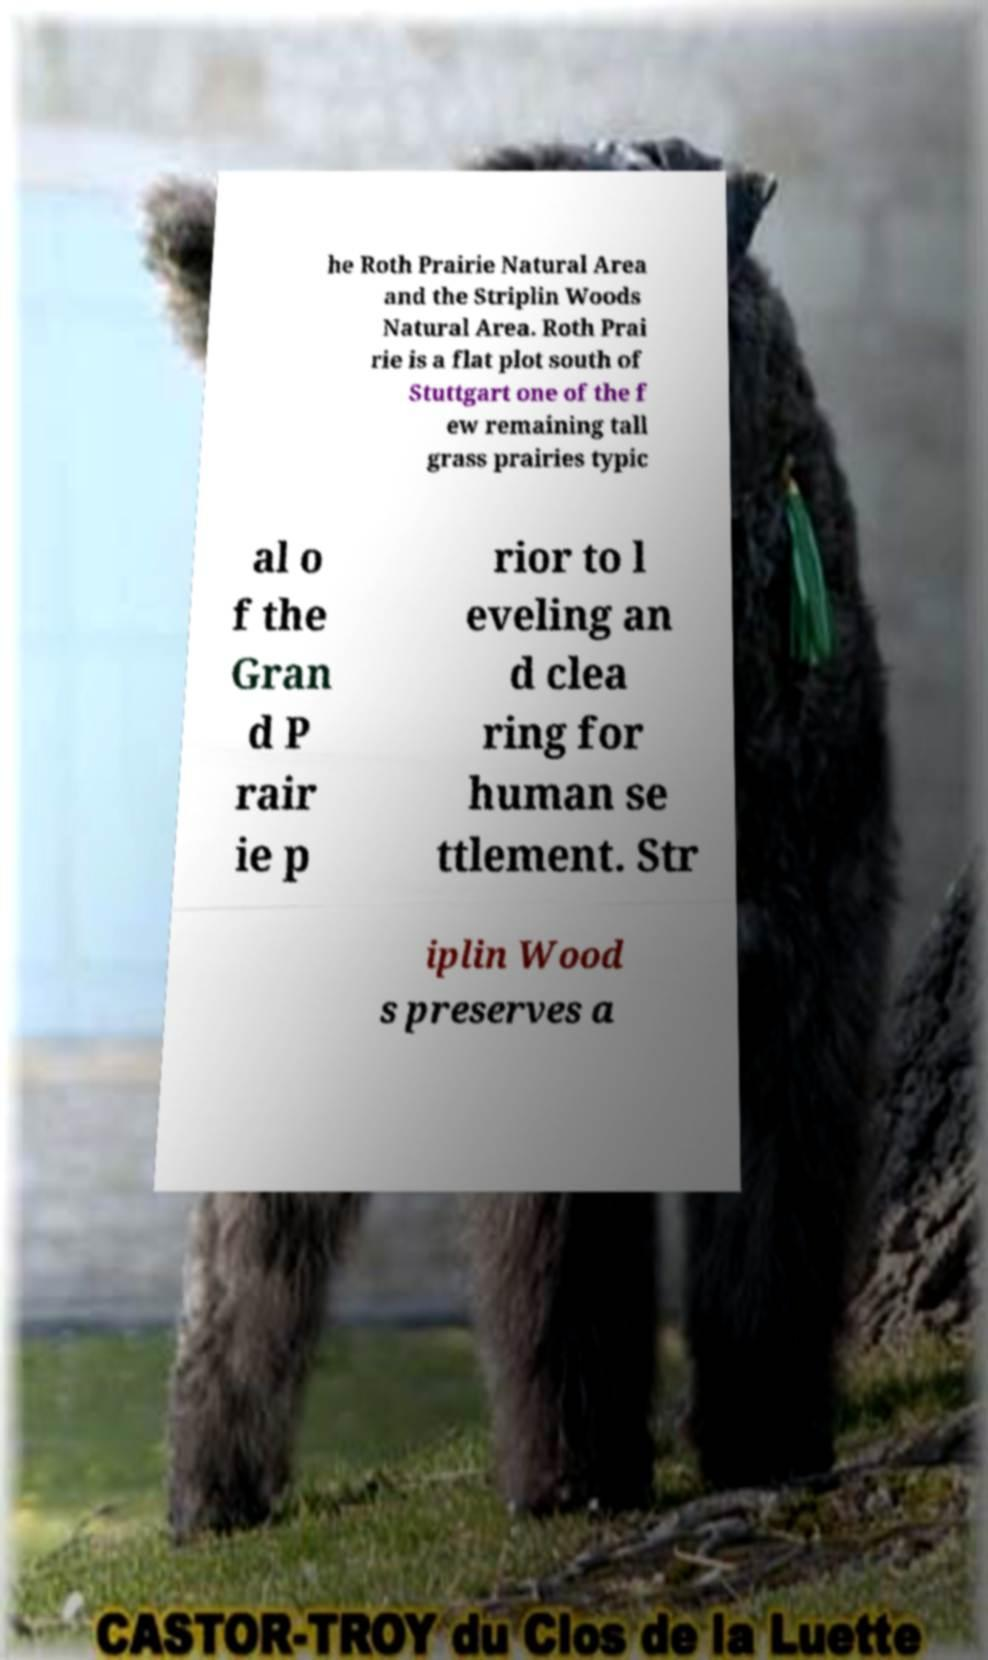Please read and relay the text visible in this image. What does it say? he Roth Prairie Natural Area and the Striplin Woods Natural Area. Roth Prai rie is a flat plot south of Stuttgart one of the f ew remaining tall grass prairies typic al o f the Gran d P rair ie p rior to l eveling an d clea ring for human se ttlement. Str iplin Wood s preserves a 